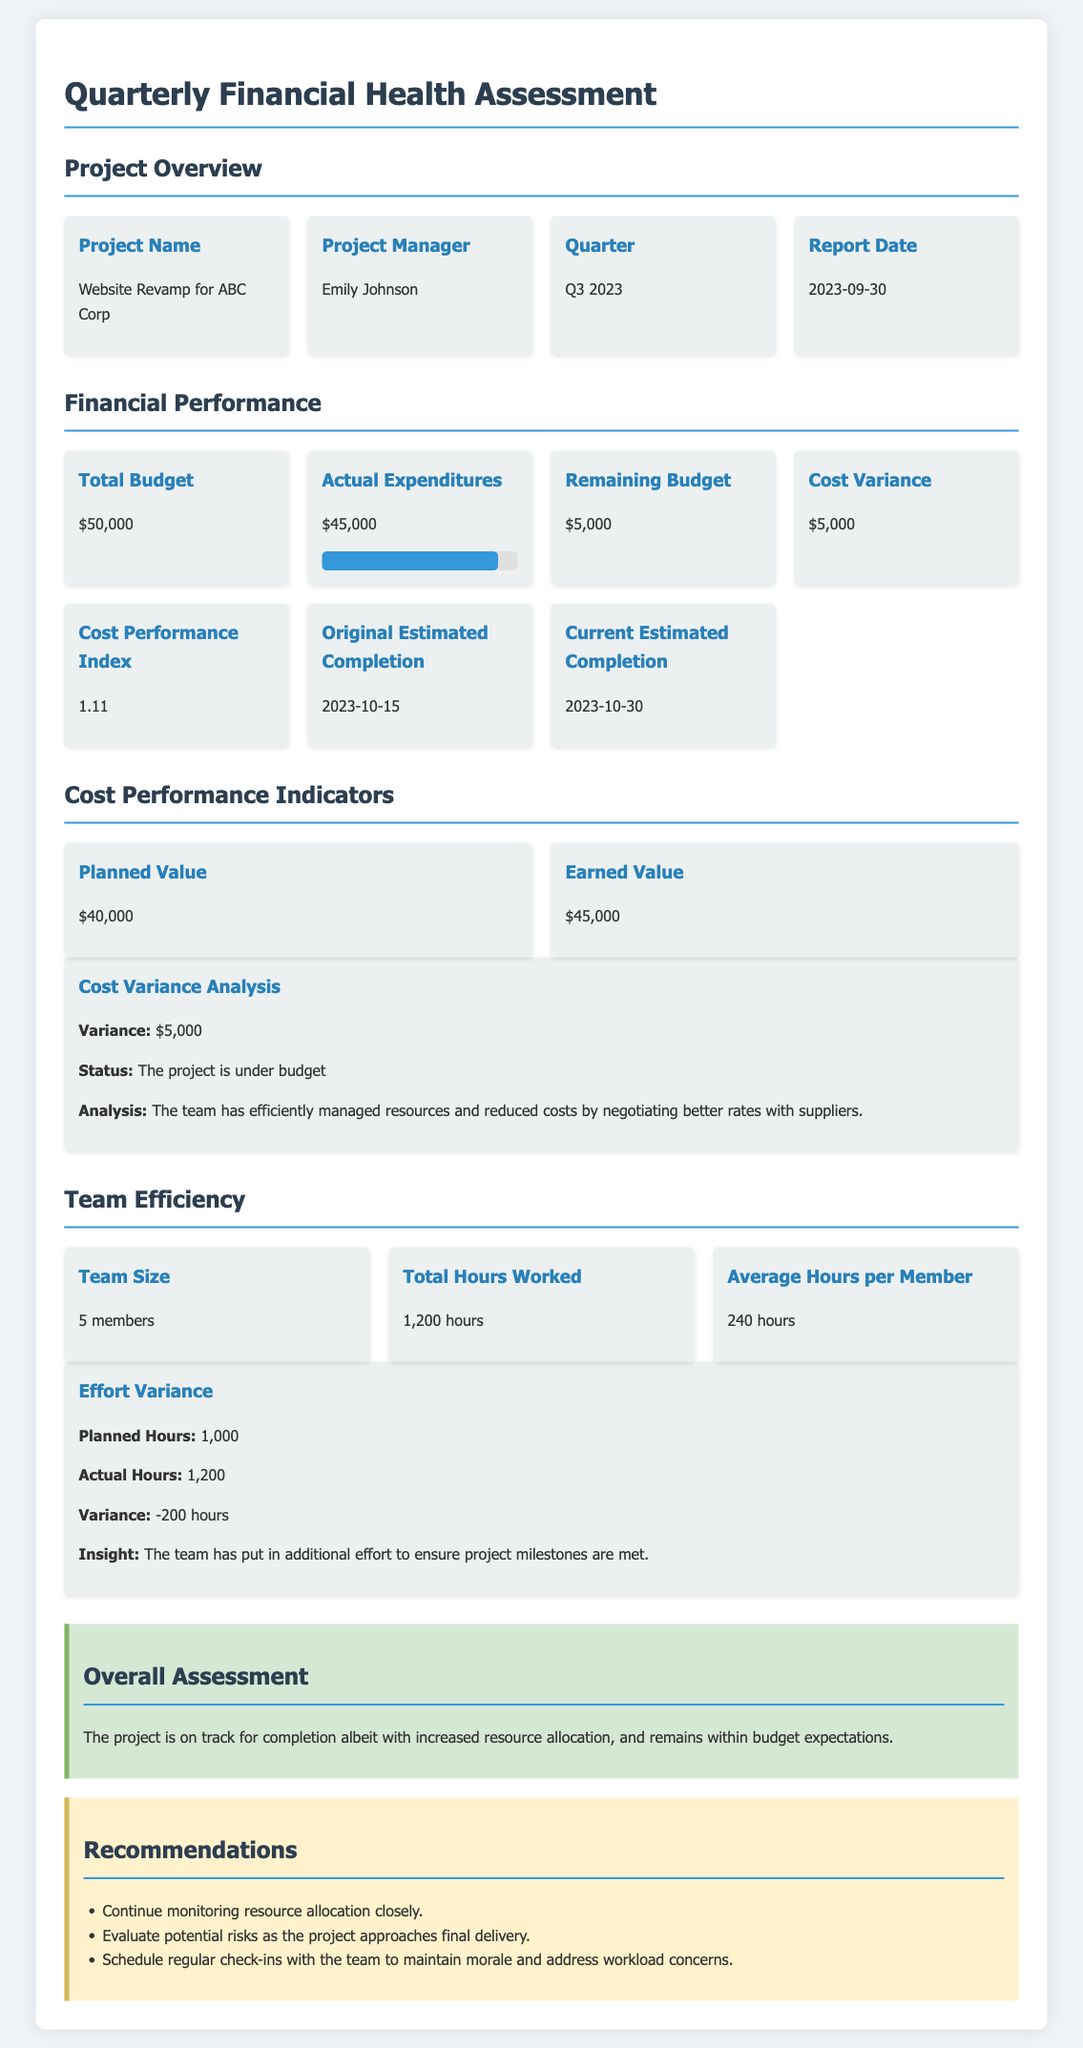What is the project name? The project name is listed under the project overview section.
Answer: Website Revamp for ABC Corp Who is the project manager? The name of the project manager is provided in the project overview section.
Answer: Emily Johnson What is the total budget? The total budget can be found in the financial performance section.
Answer: $50,000 What is the actual expenditure amount? The actual expenditures are detailed in the financial performance section.
Answer: $45,000 What is the cost performance index? The cost performance index is specified in the financial performance section.
Answer: 1.11 How many team members are there? The team size is mentioned in the team efficiency section.
Answer: 5 members What is the planned value? The planned value is provided in the cost performance indicators section.
Answer: $40,000 What was the variance in effort? The effort variance can be calculated based on the planned hours and actual hours in the team efficiency section.
Answer: -200 hours What is the overall assessment of the project? The overall assessment is summarized at the end of the document in the overall assessment section.
Answer: The project is on track for completion albeit with increased resource allocation, and remains within budget expectations 